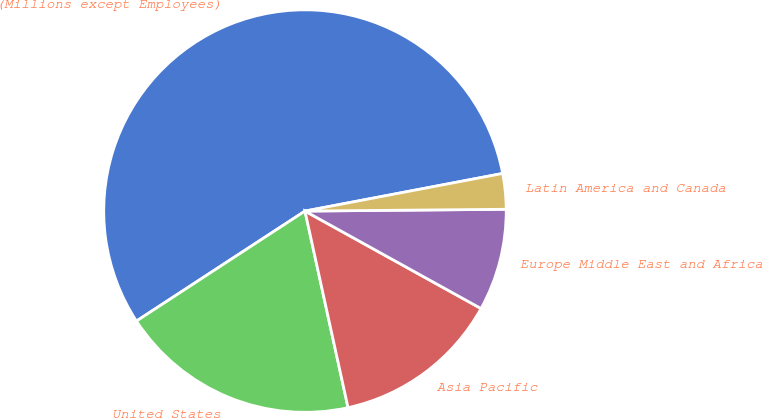<chart> <loc_0><loc_0><loc_500><loc_500><pie_chart><fcel>(Millions except Employees)<fcel>United States<fcel>Asia Pacific<fcel>Europe Middle East and Africa<fcel>Latin America and Canada<nl><fcel>56.21%<fcel>19.23%<fcel>13.52%<fcel>8.19%<fcel>2.85%<nl></chart> 